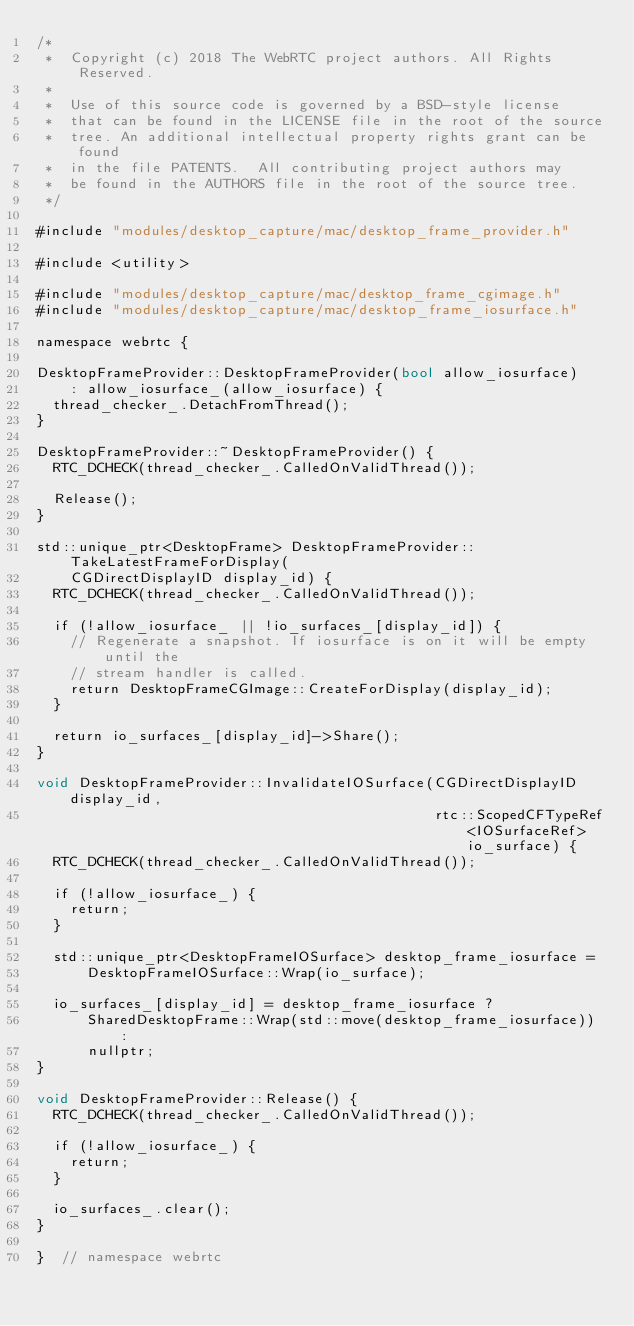<code> <loc_0><loc_0><loc_500><loc_500><_ObjectiveC_>/*
 *  Copyright (c) 2018 The WebRTC project authors. All Rights Reserved.
 *
 *  Use of this source code is governed by a BSD-style license
 *  that can be found in the LICENSE file in the root of the source
 *  tree. An additional intellectual property rights grant can be found
 *  in the file PATENTS.  All contributing project authors may
 *  be found in the AUTHORS file in the root of the source tree.
 */

#include "modules/desktop_capture/mac/desktop_frame_provider.h"

#include <utility>

#include "modules/desktop_capture/mac/desktop_frame_cgimage.h"
#include "modules/desktop_capture/mac/desktop_frame_iosurface.h"

namespace webrtc {

DesktopFrameProvider::DesktopFrameProvider(bool allow_iosurface)
    : allow_iosurface_(allow_iosurface) {
  thread_checker_.DetachFromThread();
}

DesktopFrameProvider::~DesktopFrameProvider() {
  RTC_DCHECK(thread_checker_.CalledOnValidThread());

  Release();
}

std::unique_ptr<DesktopFrame> DesktopFrameProvider::TakeLatestFrameForDisplay(
    CGDirectDisplayID display_id) {
  RTC_DCHECK(thread_checker_.CalledOnValidThread());

  if (!allow_iosurface_ || !io_surfaces_[display_id]) {
    // Regenerate a snapshot. If iosurface is on it will be empty until the
    // stream handler is called.
    return DesktopFrameCGImage::CreateForDisplay(display_id);
  }

  return io_surfaces_[display_id]->Share();
}

void DesktopFrameProvider::InvalidateIOSurface(CGDirectDisplayID display_id,
                                               rtc::ScopedCFTypeRef<IOSurfaceRef> io_surface) {
  RTC_DCHECK(thread_checker_.CalledOnValidThread());

  if (!allow_iosurface_) {
    return;
  }

  std::unique_ptr<DesktopFrameIOSurface> desktop_frame_iosurface =
      DesktopFrameIOSurface::Wrap(io_surface);

  io_surfaces_[display_id] = desktop_frame_iosurface ?
      SharedDesktopFrame::Wrap(std::move(desktop_frame_iosurface)) :
      nullptr;
}

void DesktopFrameProvider::Release() {
  RTC_DCHECK(thread_checker_.CalledOnValidThread());

  if (!allow_iosurface_) {
    return;
  }

  io_surfaces_.clear();
}

}  // namespace webrtc
</code> 